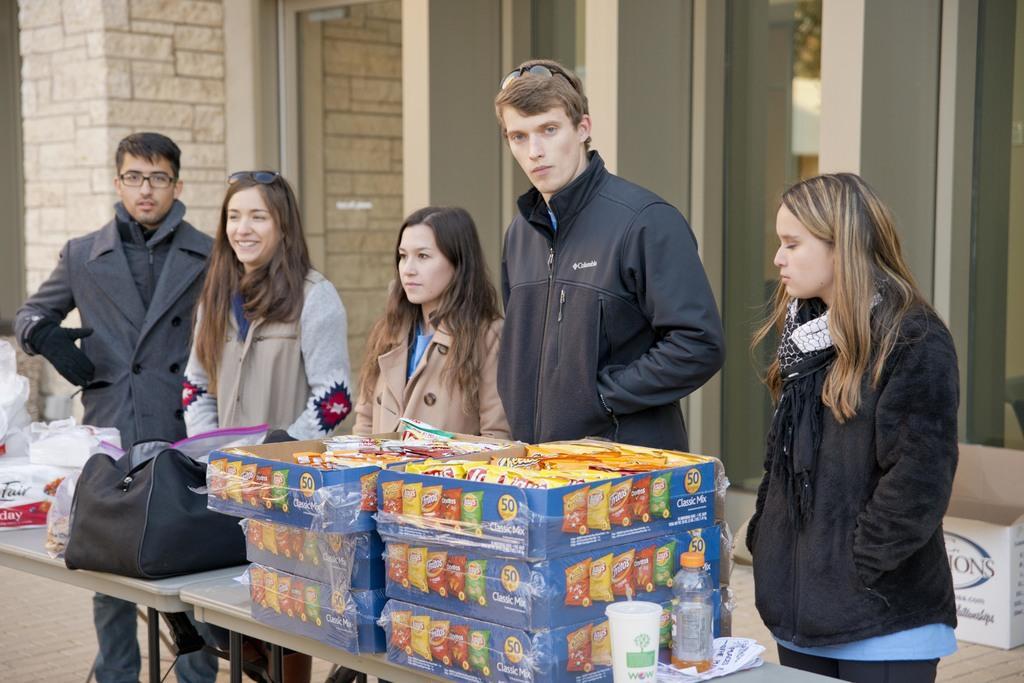Can you describe this image briefly? As we can see in the image there are buildings, few people standing over here, box and table. On table there are glasses, black color bag and boxes. 